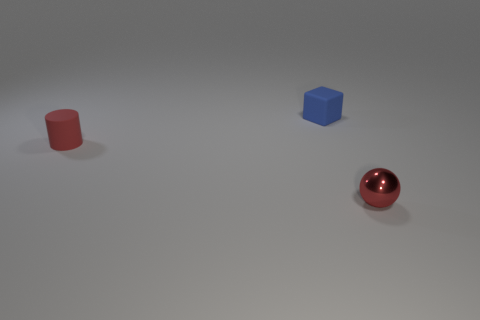Add 3 big green spheres. How many objects exist? 6 Subtract all spheres. How many objects are left? 2 Subtract all tiny blue things. Subtract all red shiny spheres. How many objects are left? 1 Add 1 small blue rubber things. How many small blue rubber things are left? 2 Add 2 red spheres. How many red spheres exist? 3 Subtract 0 cyan balls. How many objects are left? 3 